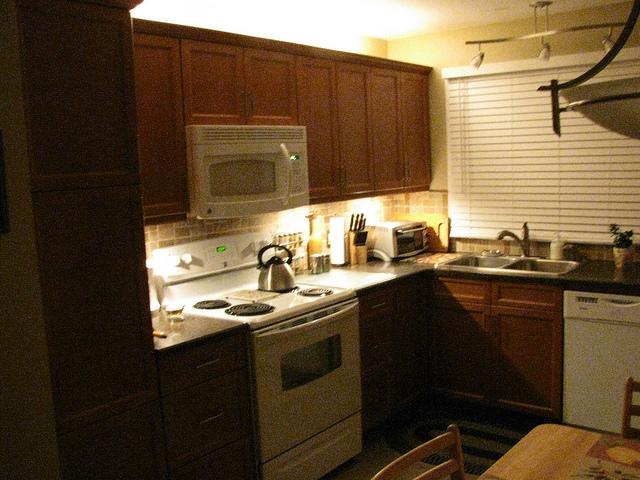How many things are on the stove?
Write a very short answer. 1. What room is this?
Give a very brief answer. Kitchen. Are any dishes visible in the sink?
Give a very brief answer. No. 